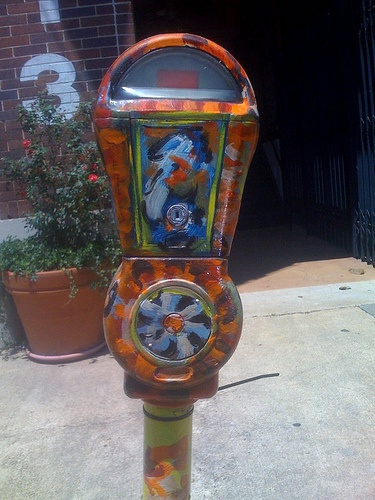Describe the objects in this image and their specific colors. I can see parking meter in purple, maroon, gray, black, and olive tones and potted plant in purple, gray, black, maroon, and brown tones in this image. 